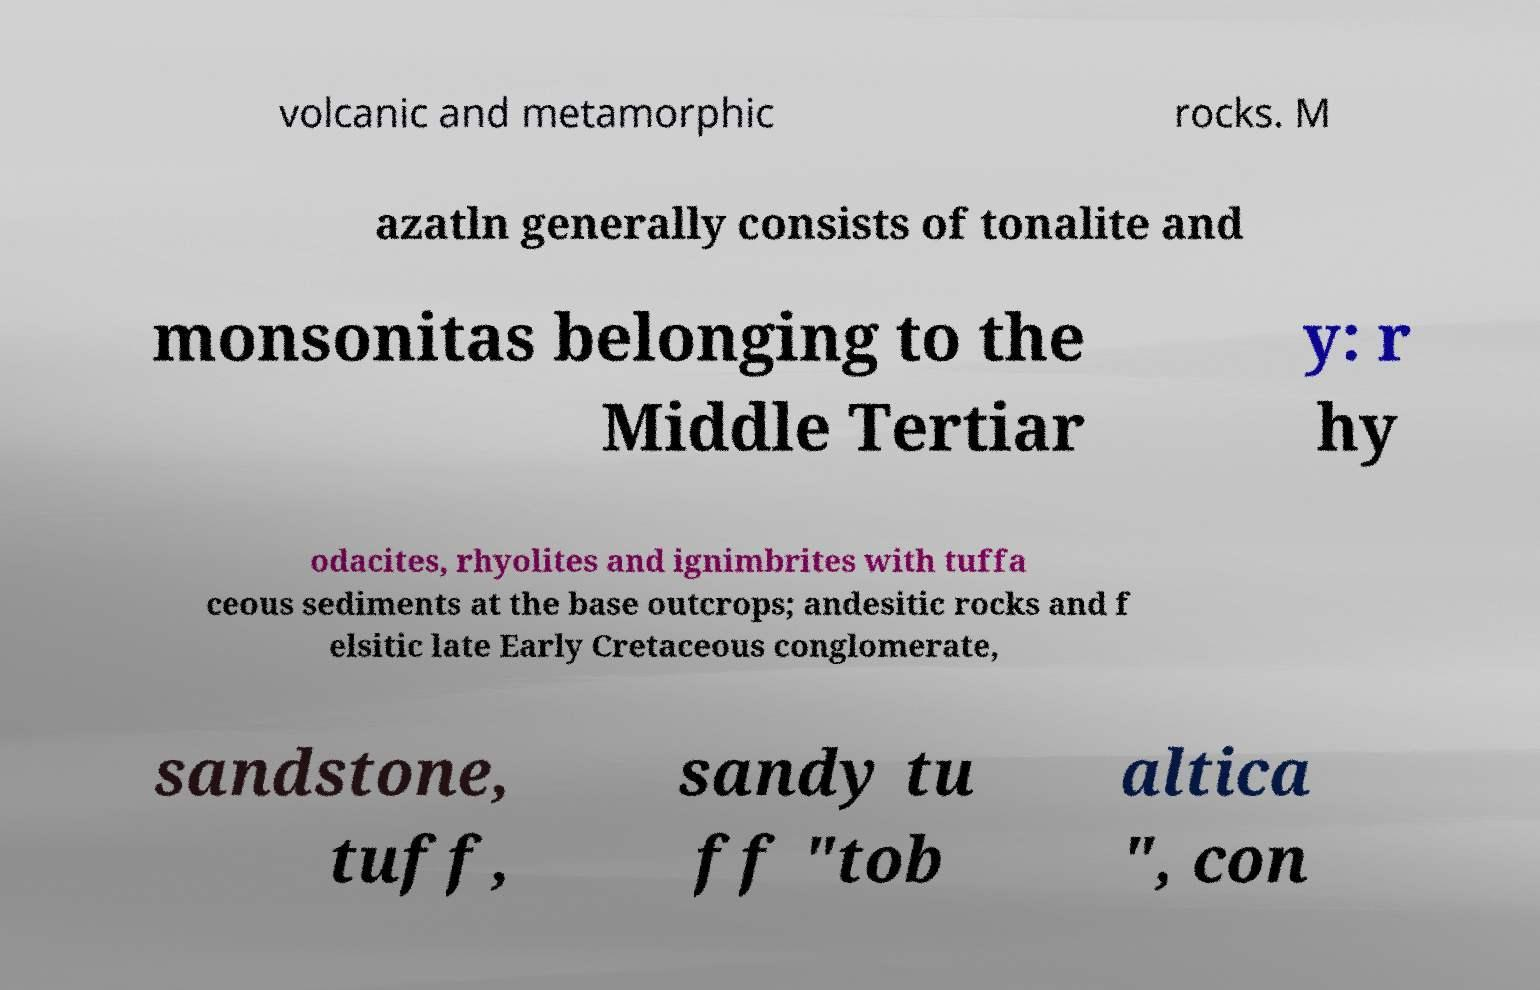There's text embedded in this image that I need extracted. Can you transcribe it verbatim? volcanic and metamorphic rocks. M azatln generally consists of tonalite and monsonitas belonging to the Middle Tertiar y: r hy odacites, rhyolites and ignimbrites with tuffa ceous sediments at the base outcrops; andesitic rocks and f elsitic late Early Cretaceous conglomerate, sandstone, tuff, sandy tu ff "tob altica ", con 